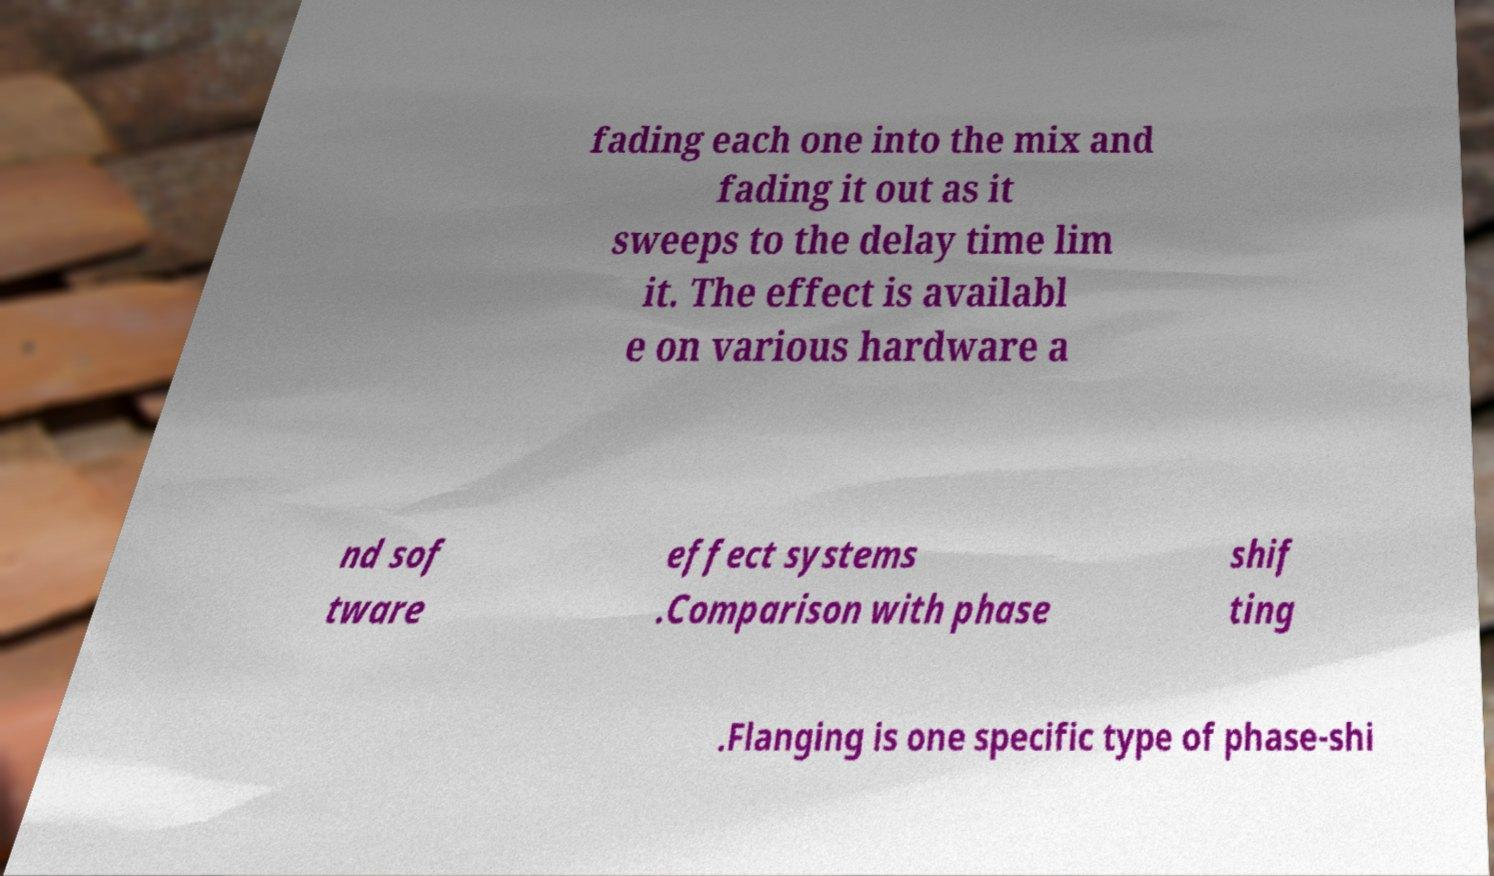I need the written content from this picture converted into text. Can you do that? fading each one into the mix and fading it out as it sweeps to the delay time lim it. The effect is availabl e on various hardware a nd sof tware effect systems .Comparison with phase shif ting .Flanging is one specific type of phase-shi 